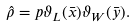<formula> <loc_0><loc_0><loc_500><loc_500>\hat { \rho } = p \vartheta _ { L } ( \bar { x } ) \vartheta _ { W } ( \bar { y } ) .</formula> 